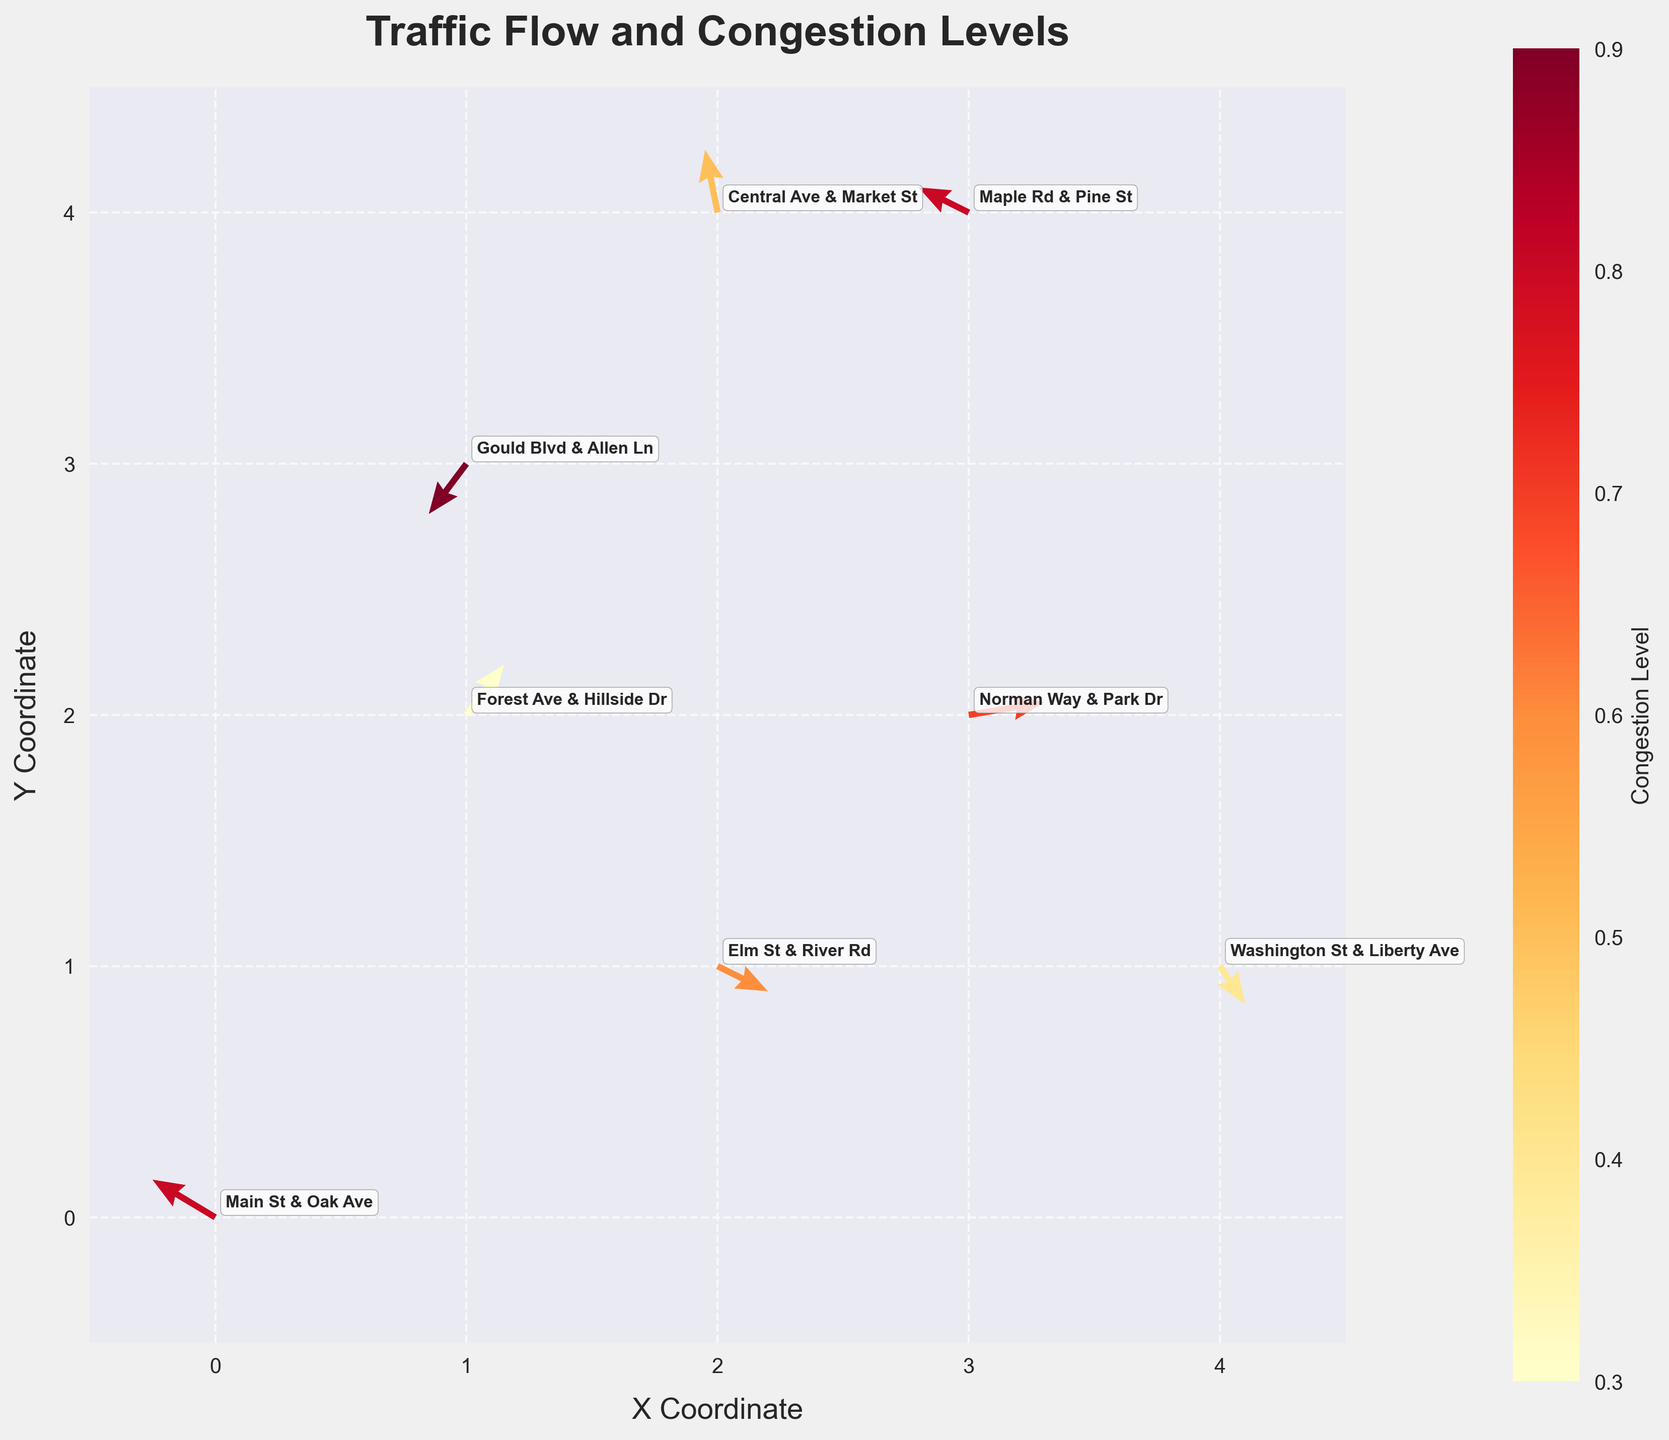Which intersection has the highest congestion level? The figure uses color intensity to represent congestion levels, with darker colors indicating higher congestion. The intersection with the highest congestion level will have the darkest color. According to the plot, Gould Blvd & Allen Ln has the darkest color, indicating the highest congestion level at 0.9.
Answer: Gould Blvd & Allen Ln What is the flow direction and magnitude at Central Ave & Market St? The arrows in the quiver plot represent the flow direction and magnitude. At Central Ave & Market St, located at coordinates (2, 4), the arrow points upward with a slight leftward deviation, and the magnitude is moderate, with x and y components of -10 and 50, respectively.
Answer: Upwards, moderate How does the traffic flow at Norman Way & Park Dr compare to Elm St & River Rd? Comparing the directions and magnitudes of the arrows at these two intersections, Norman Way & Park Dr (at coordinates 3, 2) has an arrow pointing primarily to the right with a larger magnitude (60, 10), while Elm St & River Rd (at coordinates 2, 1) has an arrow pointing downward and to the right with moderate magnitude (40, -20).
Answer: Norman Way & Park Dr has a stronger flow to the right; Elm St & River Rd has a moderate downward-right flow Which intersection shows a strong westward flow? The arrows pointing to the left indicate westward flow. The intersection where the arrow is significantly long and points left is Main St & Oak Ave, located at coordinates (0, 0), with components (-50, 30).
Answer: Main St & Oak Ave What's the average congestion level of all intersections? To find the average congestion level, add up all the congestion values and divide by the number of intersections. The congestion levels are 0.8, 0.6, 0.9, 0.7, 0.5, 0.4, 0.8, and 0.3. The sum is 4.9, and there are 8 intersections, so 4.9 / 8 equals 0.6125.
Answer: 0.6125 Which intersection has the smallest y component of flow? To find the intersection with the smallest y component of flow, look for the intersection with the most negative y value. Gould Blvd & Allen Ln has a y component of -40, which is the smallest.
Answer: Gould Blvd & Allen Ln What is the overall trend of traffic flow at Washington St & Liberty Ave? The arrow direction at Washington St & Liberty Ave, located at coordinates (4, 1), is downward with a slight rightward inclination, indicating a flow generally moving south with x and y components of 20 and -30.
Answer: Southward How many intersections have congestion levels higher than 0.5? From the figure, the intersections with congestion levels higher than 0.5 are Main St & Oak Ave (0.8), Elm St & River Rd (0.6), Gould Blvd & Allen Ln (0.9), Norman Way & Park Dr (0.7), and Maple Rd & Pine St (0.8). This counts to 5 intersections.
Answer: 5 Do more intersections have congestion levels below 0.7 or above 0.7? To determine this, count the intersections below 0.7 (Washington St & Liberty Ave = 0.4, Forest Ave & Hillside Dr = 0.3, Elm St & River Rd = 0.6, Central Ave & Market St = 0.5) and those above 0.7 (Main St & Oak Ave = 0.8, Gould Blvd & Allen Ln = 0.9, Norman Way & Park Dr = 0.7, Maple Rd & Pine St = 0.8). There are 4 below and 4 above.
Answer: Equal numbers 